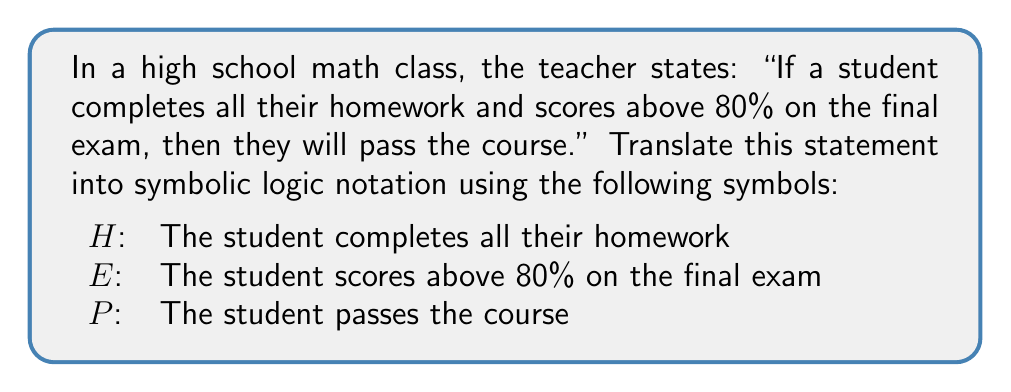Could you help me with this problem? Let's break this down step-by-step:

1. First, we need to identify the logical structure of the statement. The teacher is saying that two conditions must be met for a student to pass the course.

2. The two conditions are:
   - The student completes all their homework ($H$)
   - The student scores above 80% on the final exam ($E$)

3. These two conditions are connected by "and", which in symbolic logic is represented by the $\wedge$ symbol.

4. The statement then says that if these conditions are met, the student will pass the course. This is an "if-then" statement, which in symbolic logic is represented by the implication symbol $\rightarrow$.

5. So, we can structure our logical statement as:
   (Condition 1 AND Condition 2) $\rightarrow$ Result

6. Substituting our symbols, we get:
   $(H \wedge E) \rightarrow P$

This symbolic statement reads as: "If $H$ and $E$, then $P$", which accurately represents the original statement.
Answer: $(H \wedge E) \rightarrow P$ 